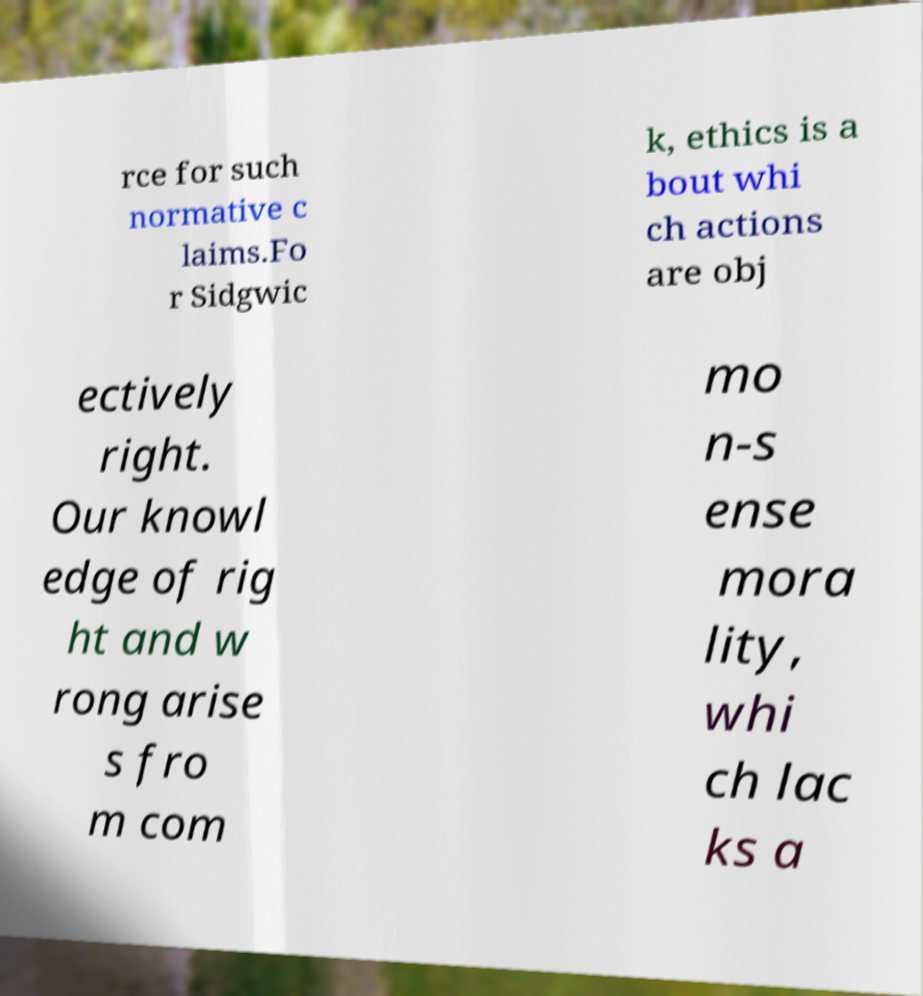Please identify and transcribe the text found in this image. rce for such normative c laims.Fo r Sidgwic k, ethics is a bout whi ch actions are obj ectively right. Our knowl edge of rig ht and w rong arise s fro m com mo n-s ense mora lity, whi ch lac ks a 